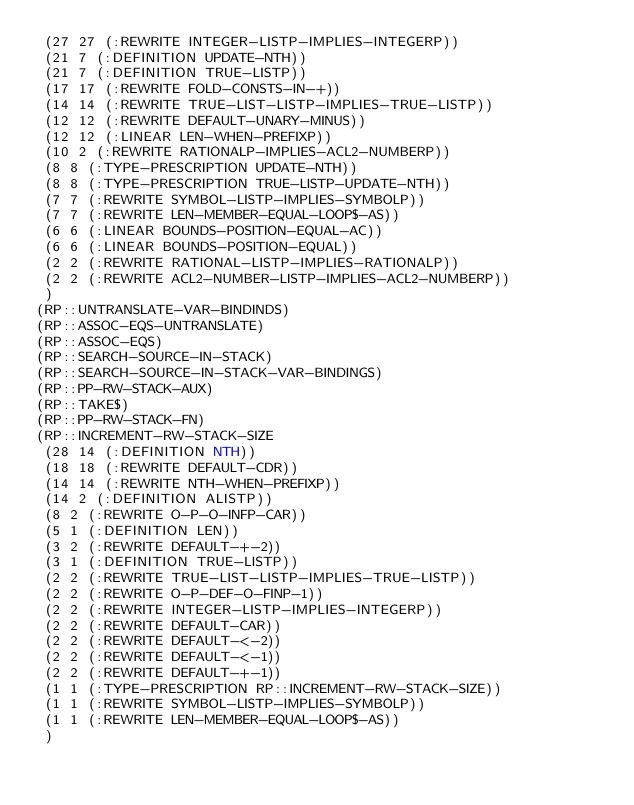<code> <loc_0><loc_0><loc_500><loc_500><_Lisp_> (27 27 (:REWRITE INTEGER-LISTP-IMPLIES-INTEGERP))
 (21 7 (:DEFINITION UPDATE-NTH))
 (21 7 (:DEFINITION TRUE-LISTP))
 (17 17 (:REWRITE FOLD-CONSTS-IN-+))
 (14 14 (:REWRITE TRUE-LIST-LISTP-IMPLIES-TRUE-LISTP))
 (12 12 (:REWRITE DEFAULT-UNARY-MINUS))
 (12 12 (:LINEAR LEN-WHEN-PREFIXP))
 (10 2 (:REWRITE RATIONALP-IMPLIES-ACL2-NUMBERP))
 (8 8 (:TYPE-PRESCRIPTION UPDATE-NTH))
 (8 8 (:TYPE-PRESCRIPTION TRUE-LISTP-UPDATE-NTH))
 (7 7 (:REWRITE SYMBOL-LISTP-IMPLIES-SYMBOLP))
 (7 7 (:REWRITE LEN-MEMBER-EQUAL-LOOP$-AS))
 (6 6 (:LINEAR BOUNDS-POSITION-EQUAL-AC))
 (6 6 (:LINEAR BOUNDS-POSITION-EQUAL))
 (2 2 (:REWRITE RATIONAL-LISTP-IMPLIES-RATIONALP))
 (2 2 (:REWRITE ACL2-NUMBER-LISTP-IMPLIES-ACL2-NUMBERP))
 )
(RP::UNTRANSLATE-VAR-BINDINDS)
(RP::ASSOC-EQS-UNTRANSLATE)
(RP::ASSOC-EQS)
(RP::SEARCH-SOURCE-IN-STACK)
(RP::SEARCH-SOURCE-IN-STACK-VAR-BINDINGS)
(RP::PP-RW-STACK-AUX)
(RP::TAKE$)
(RP::PP-RW-STACK-FN)
(RP::INCREMENT-RW-STACK-SIZE
 (28 14 (:DEFINITION NTH))
 (18 18 (:REWRITE DEFAULT-CDR))
 (14 14 (:REWRITE NTH-WHEN-PREFIXP))
 (14 2 (:DEFINITION ALISTP))
 (8 2 (:REWRITE O-P-O-INFP-CAR))
 (5 1 (:DEFINITION LEN))
 (3 2 (:REWRITE DEFAULT-+-2))
 (3 1 (:DEFINITION TRUE-LISTP))
 (2 2 (:REWRITE TRUE-LIST-LISTP-IMPLIES-TRUE-LISTP))
 (2 2 (:REWRITE O-P-DEF-O-FINP-1))
 (2 2 (:REWRITE INTEGER-LISTP-IMPLIES-INTEGERP))
 (2 2 (:REWRITE DEFAULT-CAR))
 (2 2 (:REWRITE DEFAULT-<-2))
 (2 2 (:REWRITE DEFAULT-<-1))
 (2 2 (:REWRITE DEFAULT-+-1))
 (1 1 (:TYPE-PRESCRIPTION RP::INCREMENT-RW-STACK-SIZE))
 (1 1 (:REWRITE SYMBOL-LISTP-IMPLIES-SYMBOLP))
 (1 1 (:REWRITE LEN-MEMBER-EQUAL-LOOP$-AS))
 )
</code> 